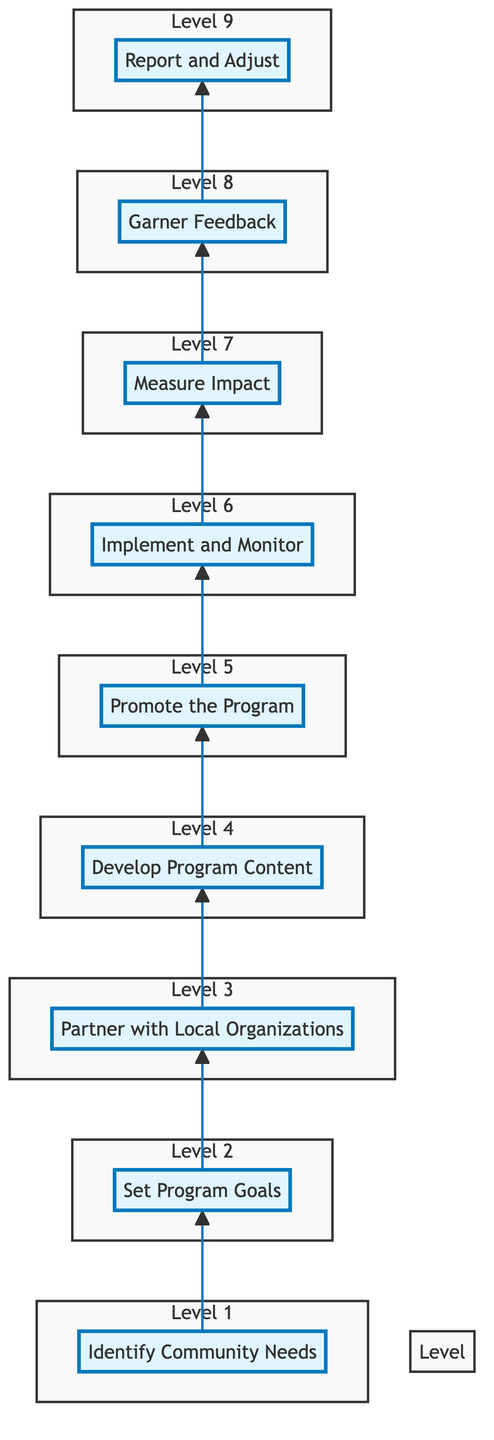What is the first step in developing a community outreach program? The diagram indicates that the first step is "Identify Community Needs," as it is the base of the flow chart. This is the initial focus before any other actions can be taken.
Answer: Identify Community Needs How many levels are there in the flow chart? By counting the distinct levels presented in the flow chart, there are a total of 9 levels, each representing a sequential step in developing the outreach program.
Answer: 9 What comes after 'Promote the Program'? Referring to the flow of the chart, 'Implement and Monitor' is the next step following 'Promote the Program', showing a continued progression in the outreach development.
Answer: Implement and Monitor Which tool is suggested for promoting the program? The flow chart lists social media platforms such as 'Facebook' and 'Twitter', indicating these as tools for promotion.
Answer: Facebook What metrics are used to measure impact? According to the diagram, the metrics listed for measuring the program's impact include 'Attendance Numbers' and 'Participant Satisfaction.' Both are critical indicators for evaluating the outreach's success.
Answer: Attendance Numbers, Participant Satisfaction How do you progress from 'Measure Impact' to the next step? The flow shows a direct connection from 'Measure Impact' to 'Garner Feedback'. This indicates that after assessing the program’s effectiveness, gathering feedback is the logical next step to improve future iterations.
Answer: Garner Feedback What is one example goal for the outreach program? The flow chart provides an example goal as 'Increase library membership by 20%', illustrating a clear and measurable target related to the outreach program.
Answer: Increase library membership by 20% What is required after obtaining feedback? The flow chart specifies that the next step after garnering feedback is to 'Report and Adjust', emphasizing the importance of evaluation and modification based on community response.
Answer: Report and Adjust Which local entities are listed as potential partners? The flow chart identifies 'Local Schools', 'Non-Profits', and 'City Councils' as potential partners for the outreach program, suggesting collaboration to enhance resources and reach.
Answer: Local Schools, Non-Profits, City Councils 